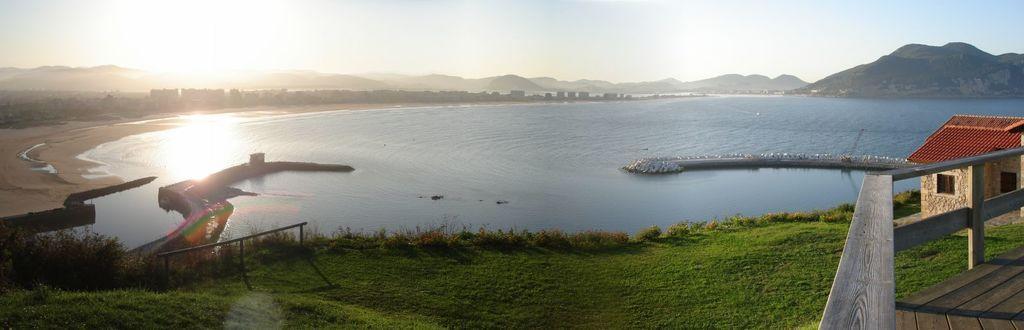In one or two sentences, can you explain what this image depicts? This is the picture of a lake. On the right side of the image there is a house and there is a wooden railing. At the back there are mountains and trees. At the top there is sky. At the bottom there is grass, water and sand. 